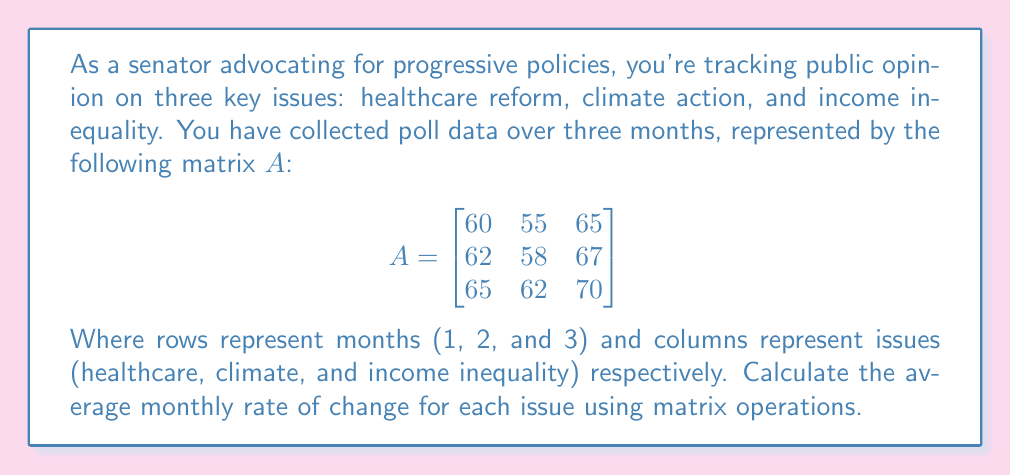Could you help me with this problem? To solve this problem, we'll follow these steps:

1) First, we need to calculate the total change for each issue over the three months. We can do this by subtracting the first row from the last row of matrix $A$:

   $$\begin{bmatrix}65 & 62 & 70\end{bmatrix} - \begin{bmatrix}60 & 55 & 65\end{bmatrix} = \begin{bmatrix}5 & 7 & 5\end{bmatrix}$$

2) This gives us the total change over two intervals (from month 1 to month 3). To get the average monthly rate of change, we need to divide by 2:

   $$\frac{1}{2}\begin{bmatrix}5 & 7 & 5\end{bmatrix} = \begin{bmatrix}2.5 & 3.5 & 2.5\end{bmatrix}$$

3) We can represent this operation as a matrix multiplication:

   $$\frac{1}{2}\begin{bmatrix}-1 & 0 & 1\end{bmatrix}A = \begin{bmatrix}2.5 & 3.5 & 2.5\end{bmatrix}$$

   Where $\begin{bmatrix}-1 & 0 & 1\end{bmatrix}$ is used to subtract the first row from the last row.

4) Therefore, the average monthly rate of change for:
   - Healthcare reform: 2.5%
   - Climate action: 3.5%
   - Income inequality: 2.5%
Answer: $\begin{bmatrix}2.5 & 3.5 & 2.5\end{bmatrix}$ 